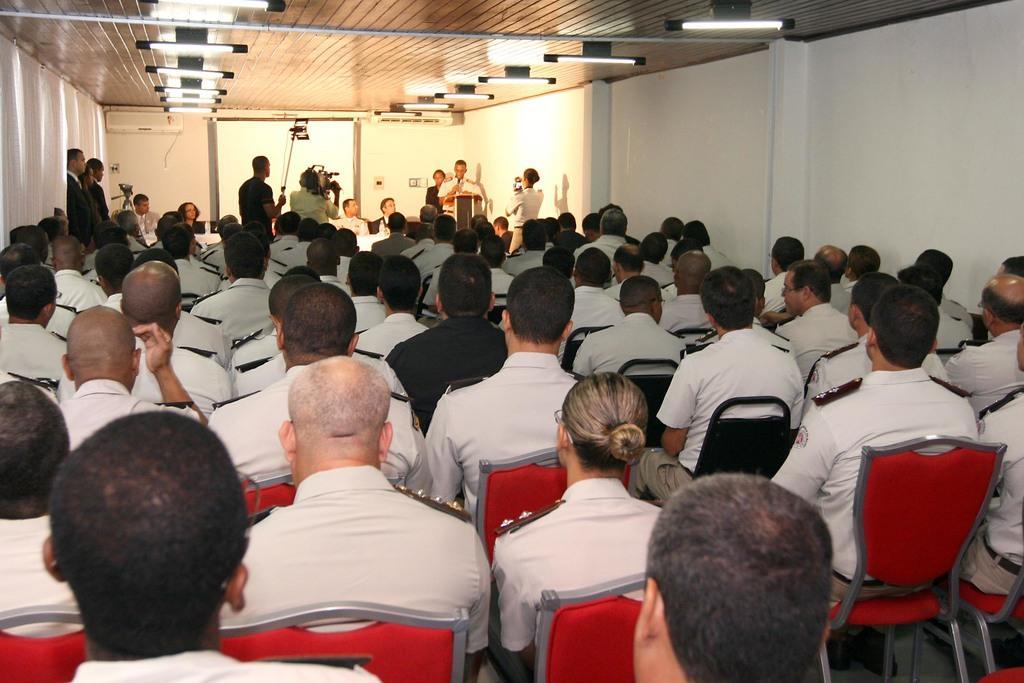In one or two sentences, can you explain what this image depicts? In the picture we can see a people sitting on a chairs, in the background we can see a screen and a persons standing and one person holding camera, to the ceiling we can see lights. 